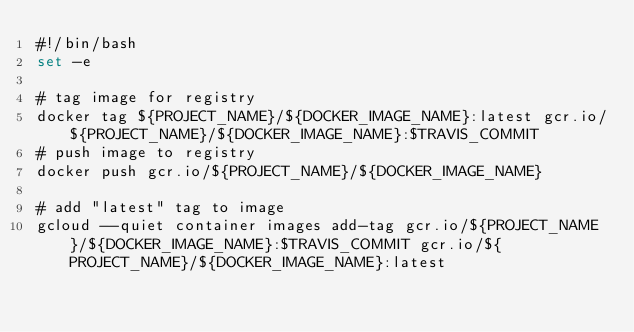<code> <loc_0><loc_0><loc_500><loc_500><_Bash_>#!/bin/bash
set -e

# tag image for registry
docker tag ${PROJECT_NAME}/${DOCKER_IMAGE_NAME}:latest gcr.io/${PROJECT_NAME}/${DOCKER_IMAGE_NAME}:$TRAVIS_COMMIT
# push image to registry
docker push gcr.io/${PROJECT_NAME}/${DOCKER_IMAGE_NAME}

# add "latest" tag to image
gcloud --quiet container images add-tag gcr.io/${PROJECT_NAME}/${DOCKER_IMAGE_NAME}:$TRAVIS_COMMIT gcr.io/${PROJECT_NAME}/${DOCKER_IMAGE_NAME}:latest
</code> 